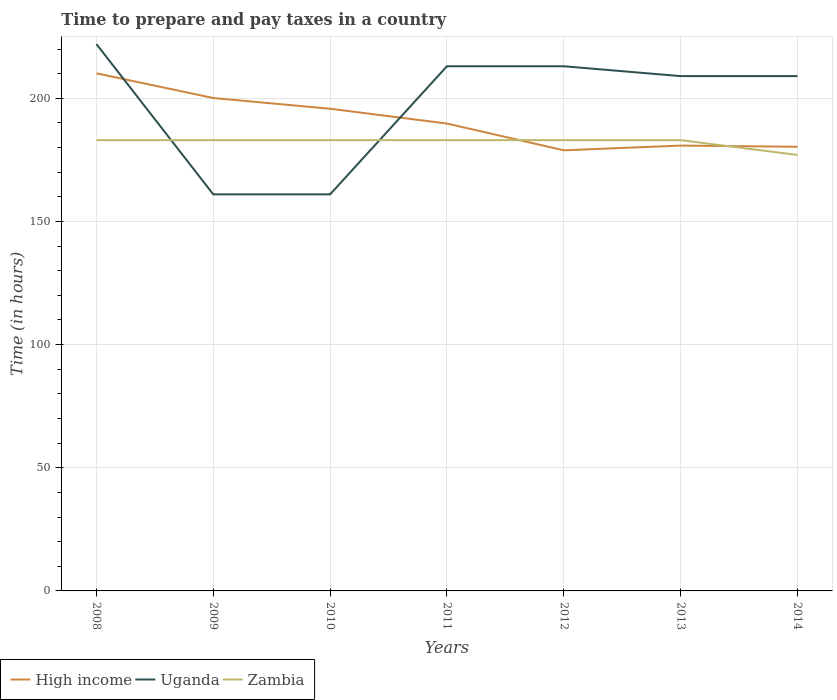Is the number of lines equal to the number of legend labels?
Keep it short and to the point. Yes. Across all years, what is the maximum number of hours required to prepare and pay taxes in High income?
Offer a terse response. 178.88. What is the total number of hours required to prepare and pay taxes in Uganda in the graph?
Provide a succinct answer. -48. What is the difference between the highest and the second highest number of hours required to prepare and pay taxes in Uganda?
Give a very brief answer. 61. What is the difference between the highest and the lowest number of hours required to prepare and pay taxes in Uganda?
Ensure brevity in your answer.  5. How many lines are there?
Offer a very short reply. 3. How many years are there in the graph?
Make the answer very short. 7. Are the values on the major ticks of Y-axis written in scientific E-notation?
Your answer should be compact. No. Does the graph contain any zero values?
Give a very brief answer. No. Does the graph contain grids?
Ensure brevity in your answer.  Yes. Where does the legend appear in the graph?
Give a very brief answer. Bottom left. How many legend labels are there?
Make the answer very short. 3. What is the title of the graph?
Offer a terse response. Time to prepare and pay taxes in a country. Does "Micronesia" appear as one of the legend labels in the graph?
Provide a succinct answer. No. What is the label or title of the Y-axis?
Offer a very short reply. Time (in hours). What is the Time (in hours) of High income in 2008?
Your response must be concise. 210.13. What is the Time (in hours) in Uganda in 2008?
Provide a short and direct response. 222. What is the Time (in hours) in Zambia in 2008?
Keep it short and to the point. 183. What is the Time (in hours) in High income in 2009?
Give a very brief answer. 200.1. What is the Time (in hours) of Uganda in 2009?
Give a very brief answer. 161. What is the Time (in hours) of Zambia in 2009?
Your answer should be compact. 183. What is the Time (in hours) in High income in 2010?
Give a very brief answer. 195.75. What is the Time (in hours) in Uganda in 2010?
Offer a terse response. 161. What is the Time (in hours) of Zambia in 2010?
Your answer should be compact. 183. What is the Time (in hours) in High income in 2011?
Give a very brief answer. 189.74. What is the Time (in hours) of Uganda in 2011?
Offer a terse response. 213. What is the Time (in hours) of Zambia in 2011?
Make the answer very short. 183. What is the Time (in hours) of High income in 2012?
Ensure brevity in your answer.  178.88. What is the Time (in hours) of Uganda in 2012?
Your answer should be compact. 213. What is the Time (in hours) in Zambia in 2012?
Make the answer very short. 183. What is the Time (in hours) in High income in 2013?
Keep it short and to the point. 180.8. What is the Time (in hours) in Uganda in 2013?
Ensure brevity in your answer.  209. What is the Time (in hours) in Zambia in 2013?
Your answer should be compact. 183. What is the Time (in hours) of High income in 2014?
Give a very brief answer. 180.32. What is the Time (in hours) in Uganda in 2014?
Your response must be concise. 209. What is the Time (in hours) in Zambia in 2014?
Your answer should be compact. 177. Across all years, what is the maximum Time (in hours) in High income?
Offer a terse response. 210.13. Across all years, what is the maximum Time (in hours) of Uganda?
Keep it short and to the point. 222. Across all years, what is the maximum Time (in hours) of Zambia?
Your response must be concise. 183. Across all years, what is the minimum Time (in hours) in High income?
Make the answer very short. 178.88. Across all years, what is the minimum Time (in hours) of Uganda?
Ensure brevity in your answer.  161. Across all years, what is the minimum Time (in hours) in Zambia?
Your answer should be compact. 177. What is the total Time (in hours) in High income in the graph?
Provide a succinct answer. 1335.72. What is the total Time (in hours) of Uganda in the graph?
Your answer should be very brief. 1388. What is the total Time (in hours) in Zambia in the graph?
Offer a very short reply. 1275. What is the difference between the Time (in hours) of High income in 2008 and that in 2009?
Make the answer very short. 10.03. What is the difference between the Time (in hours) of Uganda in 2008 and that in 2009?
Provide a succinct answer. 61. What is the difference between the Time (in hours) in High income in 2008 and that in 2010?
Offer a terse response. 14.38. What is the difference between the Time (in hours) in Uganda in 2008 and that in 2010?
Offer a very short reply. 61. What is the difference between the Time (in hours) in Zambia in 2008 and that in 2010?
Provide a succinct answer. 0. What is the difference between the Time (in hours) of High income in 2008 and that in 2011?
Make the answer very short. 20.39. What is the difference between the Time (in hours) of High income in 2008 and that in 2012?
Offer a very short reply. 31.25. What is the difference between the Time (in hours) in Uganda in 2008 and that in 2012?
Your answer should be very brief. 9. What is the difference between the Time (in hours) in High income in 2008 and that in 2013?
Give a very brief answer. 29.33. What is the difference between the Time (in hours) in Uganda in 2008 and that in 2013?
Ensure brevity in your answer.  13. What is the difference between the Time (in hours) in Zambia in 2008 and that in 2013?
Ensure brevity in your answer.  0. What is the difference between the Time (in hours) in High income in 2008 and that in 2014?
Provide a succinct answer. 29.81. What is the difference between the Time (in hours) in Zambia in 2008 and that in 2014?
Your answer should be very brief. 6. What is the difference between the Time (in hours) of High income in 2009 and that in 2010?
Your answer should be very brief. 4.35. What is the difference between the Time (in hours) in High income in 2009 and that in 2011?
Provide a short and direct response. 10.36. What is the difference between the Time (in hours) of Uganda in 2009 and that in 2011?
Your answer should be very brief. -52. What is the difference between the Time (in hours) of High income in 2009 and that in 2012?
Give a very brief answer. 21.22. What is the difference between the Time (in hours) in Uganda in 2009 and that in 2012?
Give a very brief answer. -52. What is the difference between the Time (in hours) in Zambia in 2009 and that in 2012?
Your answer should be compact. 0. What is the difference between the Time (in hours) of High income in 2009 and that in 2013?
Provide a short and direct response. 19.3. What is the difference between the Time (in hours) of Uganda in 2009 and that in 2013?
Your answer should be compact. -48. What is the difference between the Time (in hours) of High income in 2009 and that in 2014?
Your response must be concise. 19.79. What is the difference between the Time (in hours) in Uganda in 2009 and that in 2014?
Your answer should be very brief. -48. What is the difference between the Time (in hours) in Zambia in 2009 and that in 2014?
Your answer should be compact. 6. What is the difference between the Time (in hours) in High income in 2010 and that in 2011?
Your response must be concise. 6.01. What is the difference between the Time (in hours) in Uganda in 2010 and that in 2011?
Provide a succinct answer. -52. What is the difference between the Time (in hours) in High income in 2010 and that in 2012?
Provide a short and direct response. 16.87. What is the difference between the Time (in hours) of Uganda in 2010 and that in 2012?
Ensure brevity in your answer.  -52. What is the difference between the Time (in hours) of High income in 2010 and that in 2013?
Provide a short and direct response. 14.95. What is the difference between the Time (in hours) of Uganda in 2010 and that in 2013?
Keep it short and to the point. -48. What is the difference between the Time (in hours) of High income in 2010 and that in 2014?
Your answer should be very brief. 15.43. What is the difference between the Time (in hours) in Uganda in 2010 and that in 2014?
Your response must be concise. -48. What is the difference between the Time (in hours) in High income in 2011 and that in 2012?
Your answer should be very brief. 10.86. What is the difference between the Time (in hours) in Uganda in 2011 and that in 2012?
Offer a terse response. 0. What is the difference between the Time (in hours) in High income in 2011 and that in 2013?
Ensure brevity in your answer.  8.94. What is the difference between the Time (in hours) in Zambia in 2011 and that in 2013?
Your response must be concise. 0. What is the difference between the Time (in hours) of High income in 2011 and that in 2014?
Offer a terse response. 9.42. What is the difference between the Time (in hours) of Uganda in 2011 and that in 2014?
Keep it short and to the point. 4. What is the difference between the Time (in hours) in Zambia in 2011 and that in 2014?
Provide a succinct answer. 6. What is the difference between the Time (in hours) of High income in 2012 and that in 2013?
Your answer should be very brief. -1.92. What is the difference between the Time (in hours) in High income in 2012 and that in 2014?
Provide a succinct answer. -1.44. What is the difference between the Time (in hours) in Uganda in 2012 and that in 2014?
Ensure brevity in your answer.  4. What is the difference between the Time (in hours) of Zambia in 2012 and that in 2014?
Make the answer very short. 6. What is the difference between the Time (in hours) of High income in 2013 and that in 2014?
Offer a very short reply. 0.48. What is the difference between the Time (in hours) in Zambia in 2013 and that in 2014?
Your answer should be compact. 6. What is the difference between the Time (in hours) in High income in 2008 and the Time (in hours) in Uganda in 2009?
Give a very brief answer. 49.13. What is the difference between the Time (in hours) in High income in 2008 and the Time (in hours) in Zambia in 2009?
Your answer should be compact. 27.13. What is the difference between the Time (in hours) in Uganda in 2008 and the Time (in hours) in Zambia in 2009?
Keep it short and to the point. 39. What is the difference between the Time (in hours) of High income in 2008 and the Time (in hours) of Uganda in 2010?
Offer a terse response. 49.13. What is the difference between the Time (in hours) of High income in 2008 and the Time (in hours) of Zambia in 2010?
Keep it short and to the point. 27.13. What is the difference between the Time (in hours) in Uganda in 2008 and the Time (in hours) in Zambia in 2010?
Keep it short and to the point. 39. What is the difference between the Time (in hours) in High income in 2008 and the Time (in hours) in Uganda in 2011?
Give a very brief answer. -2.87. What is the difference between the Time (in hours) of High income in 2008 and the Time (in hours) of Zambia in 2011?
Your answer should be compact. 27.13. What is the difference between the Time (in hours) of High income in 2008 and the Time (in hours) of Uganda in 2012?
Your answer should be very brief. -2.87. What is the difference between the Time (in hours) in High income in 2008 and the Time (in hours) in Zambia in 2012?
Offer a terse response. 27.13. What is the difference between the Time (in hours) of Uganda in 2008 and the Time (in hours) of Zambia in 2012?
Keep it short and to the point. 39. What is the difference between the Time (in hours) of High income in 2008 and the Time (in hours) of Uganda in 2013?
Give a very brief answer. 1.13. What is the difference between the Time (in hours) of High income in 2008 and the Time (in hours) of Zambia in 2013?
Provide a succinct answer. 27.13. What is the difference between the Time (in hours) of High income in 2008 and the Time (in hours) of Uganda in 2014?
Keep it short and to the point. 1.13. What is the difference between the Time (in hours) of High income in 2008 and the Time (in hours) of Zambia in 2014?
Your answer should be compact. 33.13. What is the difference between the Time (in hours) in Uganda in 2008 and the Time (in hours) in Zambia in 2014?
Provide a succinct answer. 45. What is the difference between the Time (in hours) in High income in 2009 and the Time (in hours) in Uganda in 2010?
Your answer should be compact. 39.1. What is the difference between the Time (in hours) in High income in 2009 and the Time (in hours) in Zambia in 2010?
Your answer should be very brief. 17.1. What is the difference between the Time (in hours) of Uganda in 2009 and the Time (in hours) of Zambia in 2010?
Provide a succinct answer. -22. What is the difference between the Time (in hours) of High income in 2009 and the Time (in hours) of Uganda in 2011?
Make the answer very short. -12.9. What is the difference between the Time (in hours) in High income in 2009 and the Time (in hours) in Zambia in 2011?
Ensure brevity in your answer.  17.1. What is the difference between the Time (in hours) of Uganda in 2009 and the Time (in hours) of Zambia in 2011?
Make the answer very short. -22. What is the difference between the Time (in hours) in High income in 2009 and the Time (in hours) in Uganda in 2012?
Offer a terse response. -12.9. What is the difference between the Time (in hours) of High income in 2009 and the Time (in hours) of Zambia in 2012?
Offer a very short reply. 17.1. What is the difference between the Time (in hours) of High income in 2009 and the Time (in hours) of Uganda in 2013?
Make the answer very short. -8.9. What is the difference between the Time (in hours) of High income in 2009 and the Time (in hours) of Zambia in 2013?
Provide a short and direct response. 17.1. What is the difference between the Time (in hours) of Uganda in 2009 and the Time (in hours) of Zambia in 2013?
Ensure brevity in your answer.  -22. What is the difference between the Time (in hours) of High income in 2009 and the Time (in hours) of Uganda in 2014?
Keep it short and to the point. -8.9. What is the difference between the Time (in hours) of High income in 2009 and the Time (in hours) of Zambia in 2014?
Give a very brief answer. 23.1. What is the difference between the Time (in hours) of High income in 2010 and the Time (in hours) of Uganda in 2011?
Your answer should be very brief. -17.25. What is the difference between the Time (in hours) in High income in 2010 and the Time (in hours) in Zambia in 2011?
Your answer should be compact. 12.75. What is the difference between the Time (in hours) in Uganda in 2010 and the Time (in hours) in Zambia in 2011?
Provide a short and direct response. -22. What is the difference between the Time (in hours) of High income in 2010 and the Time (in hours) of Uganda in 2012?
Make the answer very short. -17.25. What is the difference between the Time (in hours) of High income in 2010 and the Time (in hours) of Zambia in 2012?
Make the answer very short. 12.75. What is the difference between the Time (in hours) in High income in 2010 and the Time (in hours) in Uganda in 2013?
Your answer should be very brief. -13.25. What is the difference between the Time (in hours) in High income in 2010 and the Time (in hours) in Zambia in 2013?
Ensure brevity in your answer.  12.75. What is the difference between the Time (in hours) of Uganda in 2010 and the Time (in hours) of Zambia in 2013?
Provide a short and direct response. -22. What is the difference between the Time (in hours) of High income in 2010 and the Time (in hours) of Uganda in 2014?
Keep it short and to the point. -13.25. What is the difference between the Time (in hours) of High income in 2010 and the Time (in hours) of Zambia in 2014?
Offer a very short reply. 18.75. What is the difference between the Time (in hours) in High income in 2011 and the Time (in hours) in Uganda in 2012?
Make the answer very short. -23.26. What is the difference between the Time (in hours) in High income in 2011 and the Time (in hours) in Zambia in 2012?
Offer a very short reply. 6.74. What is the difference between the Time (in hours) in Uganda in 2011 and the Time (in hours) in Zambia in 2012?
Make the answer very short. 30. What is the difference between the Time (in hours) in High income in 2011 and the Time (in hours) in Uganda in 2013?
Your response must be concise. -19.26. What is the difference between the Time (in hours) in High income in 2011 and the Time (in hours) in Zambia in 2013?
Offer a terse response. 6.74. What is the difference between the Time (in hours) in Uganda in 2011 and the Time (in hours) in Zambia in 2013?
Offer a terse response. 30. What is the difference between the Time (in hours) in High income in 2011 and the Time (in hours) in Uganda in 2014?
Your answer should be very brief. -19.26. What is the difference between the Time (in hours) of High income in 2011 and the Time (in hours) of Zambia in 2014?
Your response must be concise. 12.74. What is the difference between the Time (in hours) in Uganda in 2011 and the Time (in hours) in Zambia in 2014?
Provide a short and direct response. 36. What is the difference between the Time (in hours) of High income in 2012 and the Time (in hours) of Uganda in 2013?
Ensure brevity in your answer.  -30.12. What is the difference between the Time (in hours) in High income in 2012 and the Time (in hours) in Zambia in 2013?
Provide a short and direct response. -4.12. What is the difference between the Time (in hours) in Uganda in 2012 and the Time (in hours) in Zambia in 2013?
Your answer should be compact. 30. What is the difference between the Time (in hours) of High income in 2012 and the Time (in hours) of Uganda in 2014?
Provide a succinct answer. -30.12. What is the difference between the Time (in hours) of High income in 2012 and the Time (in hours) of Zambia in 2014?
Provide a succinct answer. 1.88. What is the difference between the Time (in hours) of High income in 2013 and the Time (in hours) of Uganda in 2014?
Offer a terse response. -28.2. What is the difference between the Time (in hours) of High income in 2013 and the Time (in hours) of Zambia in 2014?
Keep it short and to the point. 3.8. What is the difference between the Time (in hours) in Uganda in 2013 and the Time (in hours) in Zambia in 2014?
Make the answer very short. 32. What is the average Time (in hours) of High income per year?
Your answer should be very brief. 190.82. What is the average Time (in hours) in Uganda per year?
Provide a succinct answer. 198.29. What is the average Time (in hours) of Zambia per year?
Provide a short and direct response. 182.14. In the year 2008, what is the difference between the Time (in hours) of High income and Time (in hours) of Uganda?
Keep it short and to the point. -11.87. In the year 2008, what is the difference between the Time (in hours) in High income and Time (in hours) in Zambia?
Keep it short and to the point. 27.13. In the year 2008, what is the difference between the Time (in hours) in Uganda and Time (in hours) in Zambia?
Your response must be concise. 39. In the year 2009, what is the difference between the Time (in hours) of High income and Time (in hours) of Uganda?
Keep it short and to the point. 39.1. In the year 2009, what is the difference between the Time (in hours) of High income and Time (in hours) of Zambia?
Offer a terse response. 17.1. In the year 2010, what is the difference between the Time (in hours) in High income and Time (in hours) in Uganda?
Keep it short and to the point. 34.75. In the year 2010, what is the difference between the Time (in hours) of High income and Time (in hours) of Zambia?
Keep it short and to the point. 12.75. In the year 2010, what is the difference between the Time (in hours) of Uganda and Time (in hours) of Zambia?
Provide a short and direct response. -22. In the year 2011, what is the difference between the Time (in hours) in High income and Time (in hours) in Uganda?
Offer a very short reply. -23.26. In the year 2011, what is the difference between the Time (in hours) in High income and Time (in hours) in Zambia?
Your answer should be compact. 6.74. In the year 2012, what is the difference between the Time (in hours) of High income and Time (in hours) of Uganda?
Give a very brief answer. -34.12. In the year 2012, what is the difference between the Time (in hours) in High income and Time (in hours) in Zambia?
Offer a terse response. -4.12. In the year 2013, what is the difference between the Time (in hours) of High income and Time (in hours) of Uganda?
Offer a terse response. -28.2. In the year 2013, what is the difference between the Time (in hours) in High income and Time (in hours) in Zambia?
Your answer should be compact. -2.2. In the year 2013, what is the difference between the Time (in hours) of Uganda and Time (in hours) of Zambia?
Your answer should be compact. 26. In the year 2014, what is the difference between the Time (in hours) in High income and Time (in hours) in Uganda?
Your response must be concise. -28.68. In the year 2014, what is the difference between the Time (in hours) of High income and Time (in hours) of Zambia?
Your answer should be very brief. 3.32. In the year 2014, what is the difference between the Time (in hours) of Uganda and Time (in hours) of Zambia?
Offer a very short reply. 32. What is the ratio of the Time (in hours) of High income in 2008 to that in 2009?
Your answer should be very brief. 1.05. What is the ratio of the Time (in hours) of Uganda in 2008 to that in 2009?
Your answer should be very brief. 1.38. What is the ratio of the Time (in hours) of Zambia in 2008 to that in 2009?
Your answer should be very brief. 1. What is the ratio of the Time (in hours) of High income in 2008 to that in 2010?
Your answer should be very brief. 1.07. What is the ratio of the Time (in hours) in Uganda in 2008 to that in 2010?
Ensure brevity in your answer.  1.38. What is the ratio of the Time (in hours) of Zambia in 2008 to that in 2010?
Your answer should be very brief. 1. What is the ratio of the Time (in hours) in High income in 2008 to that in 2011?
Your response must be concise. 1.11. What is the ratio of the Time (in hours) in Uganda in 2008 to that in 2011?
Ensure brevity in your answer.  1.04. What is the ratio of the Time (in hours) of Zambia in 2008 to that in 2011?
Your answer should be very brief. 1. What is the ratio of the Time (in hours) of High income in 2008 to that in 2012?
Offer a terse response. 1.17. What is the ratio of the Time (in hours) in Uganda in 2008 to that in 2012?
Offer a terse response. 1.04. What is the ratio of the Time (in hours) in High income in 2008 to that in 2013?
Provide a succinct answer. 1.16. What is the ratio of the Time (in hours) of Uganda in 2008 to that in 2013?
Your answer should be compact. 1.06. What is the ratio of the Time (in hours) in Zambia in 2008 to that in 2013?
Ensure brevity in your answer.  1. What is the ratio of the Time (in hours) in High income in 2008 to that in 2014?
Your answer should be very brief. 1.17. What is the ratio of the Time (in hours) in Uganda in 2008 to that in 2014?
Give a very brief answer. 1.06. What is the ratio of the Time (in hours) of Zambia in 2008 to that in 2014?
Offer a terse response. 1.03. What is the ratio of the Time (in hours) in High income in 2009 to that in 2010?
Provide a succinct answer. 1.02. What is the ratio of the Time (in hours) of Uganda in 2009 to that in 2010?
Give a very brief answer. 1. What is the ratio of the Time (in hours) of High income in 2009 to that in 2011?
Offer a very short reply. 1.05. What is the ratio of the Time (in hours) of Uganda in 2009 to that in 2011?
Your answer should be very brief. 0.76. What is the ratio of the Time (in hours) of High income in 2009 to that in 2012?
Keep it short and to the point. 1.12. What is the ratio of the Time (in hours) in Uganda in 2009 to that in 2012?
Provide a short and direct response. 0.76. What is the ratio of the Time (in hours) in Zambia in 2009 to that in 2012?
Your answer should be very brief. 1. What is the ratio of the Time (in hours) in High income in 2009 to that in 2013?
Provide a short and direct response. 1.11. What is the ratio of the Time (in hours) in Uganda in 2009 to that in 2013?
Ensure brevity in your answer.  0.77. What is the ratio of the Time (in hours) in Zambia in 2009 to that in 2013?
Keep it short and to the point. 1. What is the ratio of the Time (in hours) in High income in 2009 to that in 2014?
Your answer should be very brief. 1.11. What is the ratio of the Time (in hours) in Uganda in 2009 to that in 2014?
Your answer should be compact. 0.77. What is the ratio of the Time (in hours) in Zambia in 2009 to that in 2014?
Provide a succinct answer. 1.03. What is the ratio of the Time (in hours) in High income in 2010 to that in 2011?
Your answer should be compact. 1.03. What is the ratio of the Time (in hours) of Uganda in 2010 to that in 2011?
Provide a succinct answer. 0.76. What is the ratio of the Time (in hours) in High income in 2010 to that in 2012?
Your answer should be compact. 1.09. What is the ratio of the Time (in hours) in Uganda in 2010 to that in 2012?
Make the answer very short. 0.76. What is the ratio of the Time (in hours) of High income in 2010 to that in 2013?
Provide a short and direct response. 1.08. What is the ratio of the Time (in hours) in Uganda in 2010 to that in 2013?
Offer a very short reply. 0.77. What is the ratio of the Time (in hours) in High income in 2010 to that in 2014?
Your response must be concise. 1.09. What is the ratio of the Time (in hours) of Uganda in 2010 to that in 2014?
Keep it short and to the point. 0.77. What is the ratio of the Time (in hours) of Zambia in 2010 to that in 2014?
Ensure brevity in your answer.  1.03. What is the ratio of the Time (in hours) of High income in 2011 to that in 2012?
Ensure brevity in your answer.  1.06. What is the ratio of the Time (in hours) in Uganda in 2011 to that in 2012?
Your response must be concise. 1. What is the ratio of the Time (in hours) in High income in 2011 to that in 2013?
Your response must be concise. 1.05. What is the ratio of the Time (in hours) in Uganda in 2011 to that in 2013?
Offer a very short reply. 1.02. What is the ratio of the Time (in hours) in Zambia in 2011 to that in 2013?
Make the answer very short. 1. What is the ratio of the Time (in hours) of High income in 2011 to that in 2014?
Your answer should be compact. 1.05. What is the ratio of the Time (in hours) in Uganda in 2011 to that in 2014?
Offer a very short reply. 1.02. What is the ratio of the Time (in hours) of Zambia in 2011 to that in 2014?
Give a very brief answer. 1.03. What is the ratio of the Time (in hours) of High income in 2012 to that in 2013?
Keep it short and to the point. 0.99. What is the ratio of the Time (in hours) in Uganda in 2012 to that in 2013?
Your response must be concise. 1.02. What is the ratio of the Time (in hours) of High income in 2012 to that in 2014?
Ensure brevity in your answer.  0.99. What is the ratio of the Time (in hours) in Uganda in 2012 to that in 2014?
Offer a very short reply. 1.02. What is the ratio of the Time (in hours) of Zambia in 2012 to that in 2014?
Offer a terse response. 1.03. What is the ratio of the Time (in hours) in High income in 2013 to that in 2014?
Offer a terse response. 1. What is the ratio of the Time (in hours) in Zambia in 2013 to that in 2014?
Provide a short and direct response. 1.03. What is the difference between the highest and the second highest Time (in hours) in High income?
Make the answer very short. 10.03. What is the difference between the highest and the second highest Time (in hours) of Uganda?
Keep it short and to the point. 9. What is the difference between the highest and the lowest Time (in hours) in High income?
Offer a terse response. 31.25. What is the difference between the highest and the lowest Time (in hours) of Zambia?
Make the answer very short. 6. 